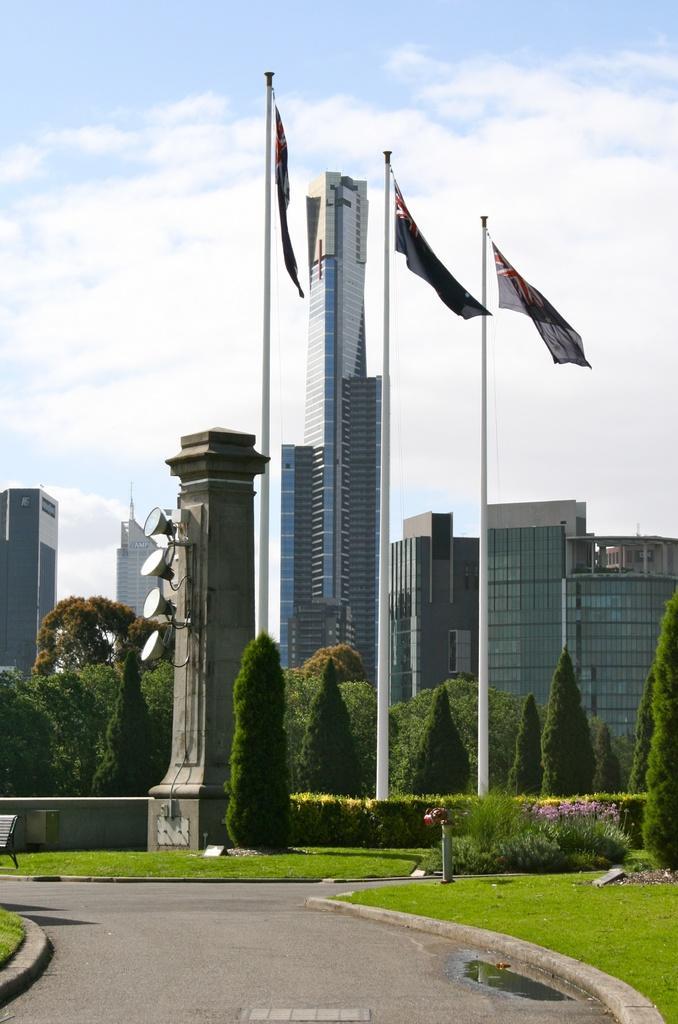Can you describe this image briefly? There is a road at the bottom of this image. There are some trees and buildings in the background. There is a sky at the top of this image. There is a pillar in the middle of this image. 